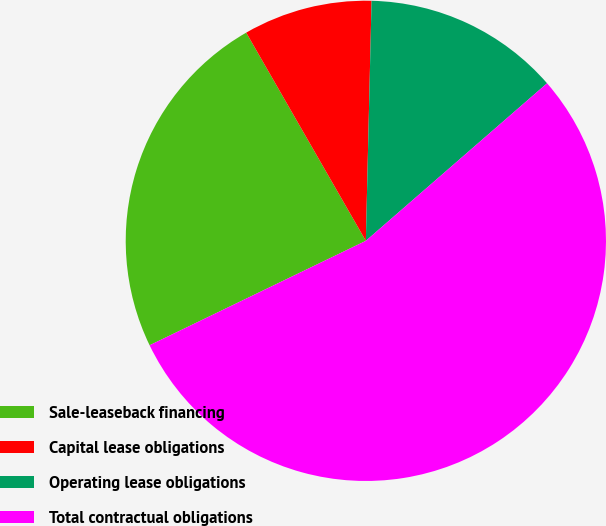<chart> <loc_0><loc_0><loc_500><loc_500><pie_chart><fcel>Sale-leaseback financing<fcel>Capital lease obligations<fcel>Operating lease obligations<fcel>Total contractual obligations<nl><fcel>23.86%<fcel>8.68%<fcel>13.23%<fcel>54.23%<nl></chart> 